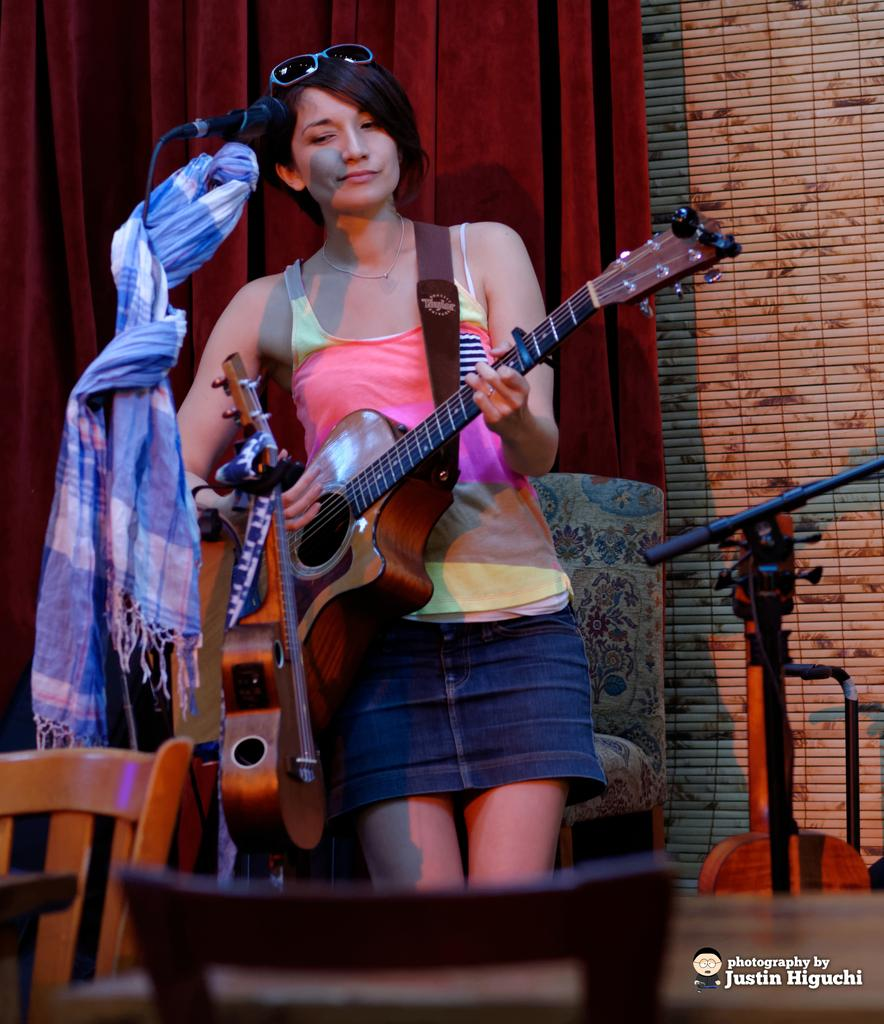What is the woman in the image doing? The woman is playing a guitar in the image. What object is in front of the woman? There is a microphone in front of the woman. What color is the curtain in the image? There is a red curtain in the image. What piece of furniture is present in the image? There is a chair in the image. How many musical instruments can be seen in the image? Since the woman is playing a guitar, there is at least one musical instrument visible. What activity is the woman's mom doing in the image? There is no mention of the woman's mom in the image, so we cannot answer this question. How does the woman get the attention of the audience in the image? The image does not show the woman interacting with an audience, so we cannot determine how she gets their attention. 